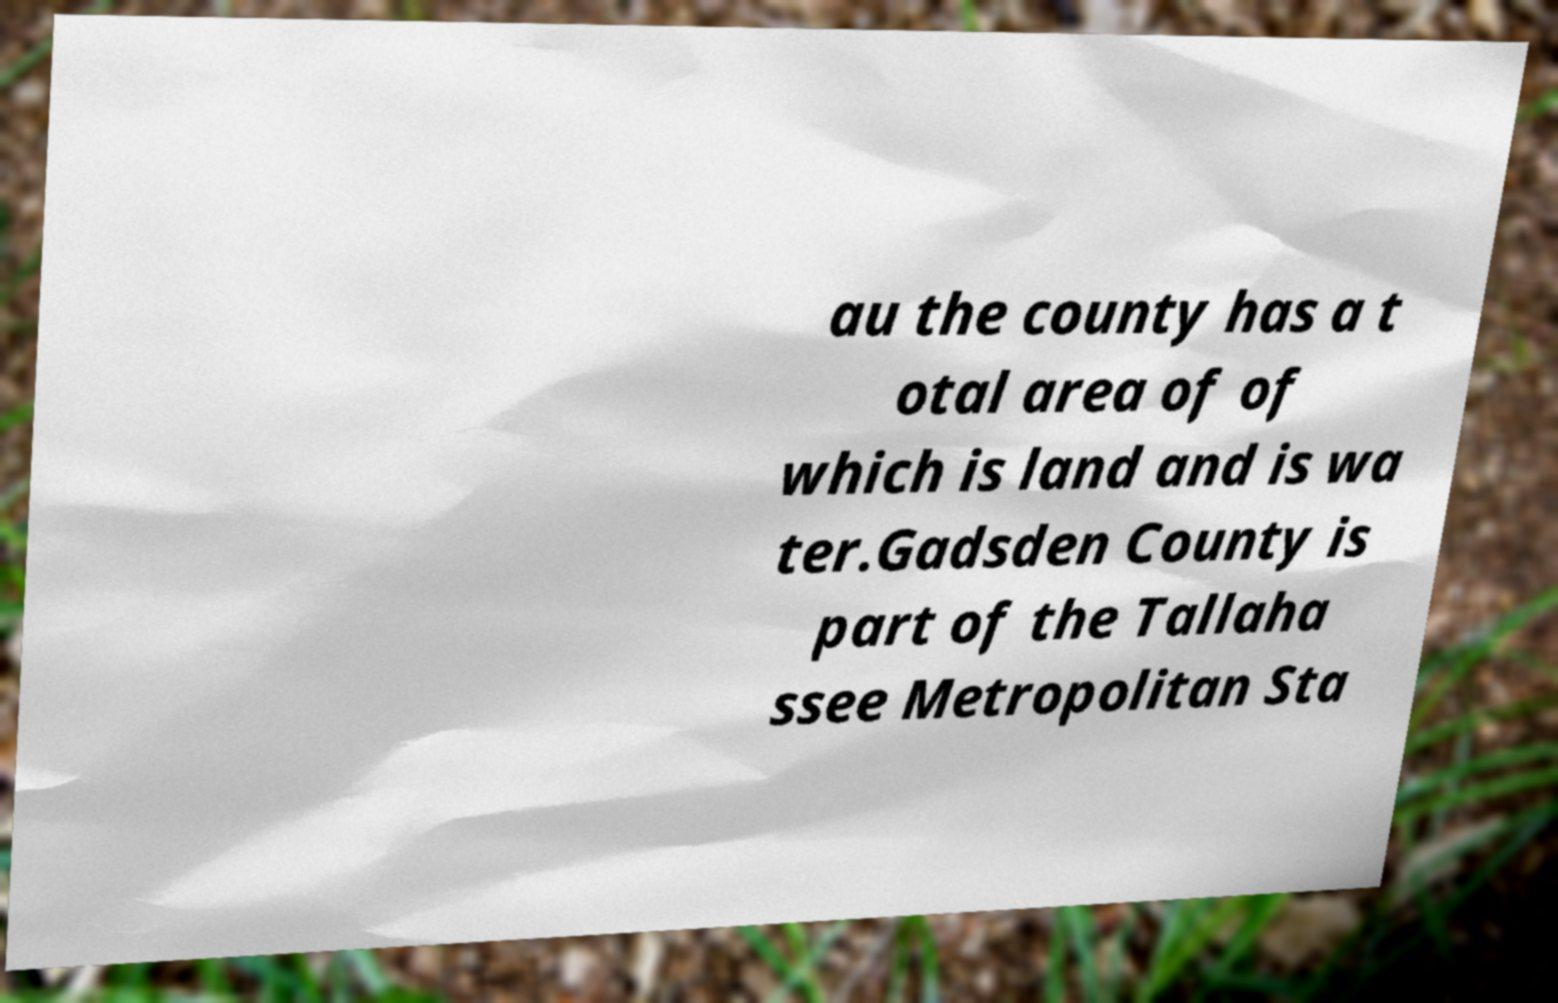Can you read and provide the text displayed in the image?This photo seems to have some interesting text. Can you extract and type it out for me? au the county has a t otal area of of which is land and is wa ter.Gadsden County is part of the Tallaha ssee Metropolitan Sta 